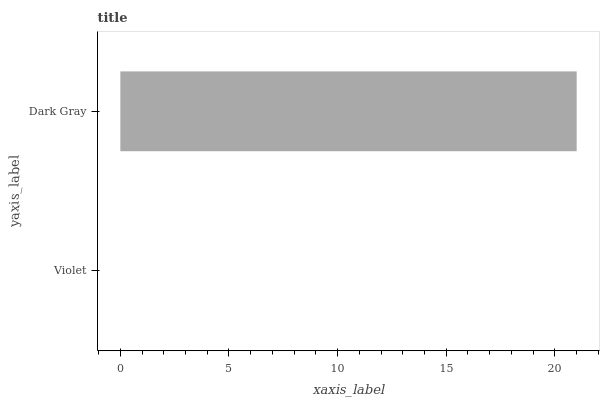Is Violet the minimum?
Answer yes or no. Yes. Is Dark Gray the maximum?
Answer yes or no. Yes. Is Dark Gray the minimum?
Answer yes or no. No. Is Dark Gray greater than Violet?
Answer yes or no. Yes. Is Violet less than Dark Gray?
Answer yes or no. Yes. Is Violet greater than Dark Gray?
Answer yes or no. No. Is Dark Gray less than Violet?
Answer yes or no. No. Is Dark Gray the high median?
Answer yes or no. Yes. Is Violet the low median?
Answer yes or no. Yes. Is Violet the high median?
Answer yes or no. No. Is Dark Gray the low median?
Answer yes or no. No. 